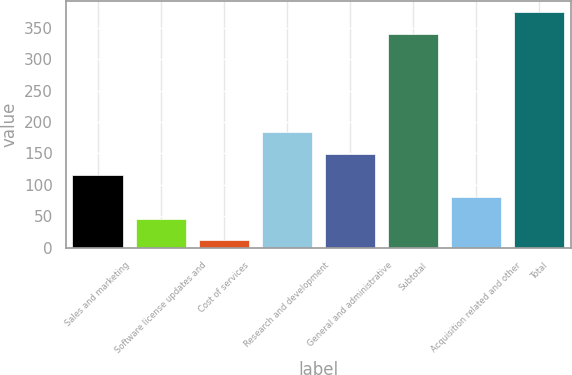Convert chart to OTSL. <chart><loc_0><loc_0><loc_500><loc_500><bar_chart><fcel>Sales and marketing<fcel>Software license updates and<fcel>Cost of services<fcel>Research and development<fcel>General and administrative<fcel>Subtotal<fcel>Acquisition related and other<fcel>Total<nl><fcel>114.9<fcel>46.3<fcel>12<fcel>183.5<fcel>149.2<fcel>340<fcel>80.6<fcel>374.3<nl></chart> 